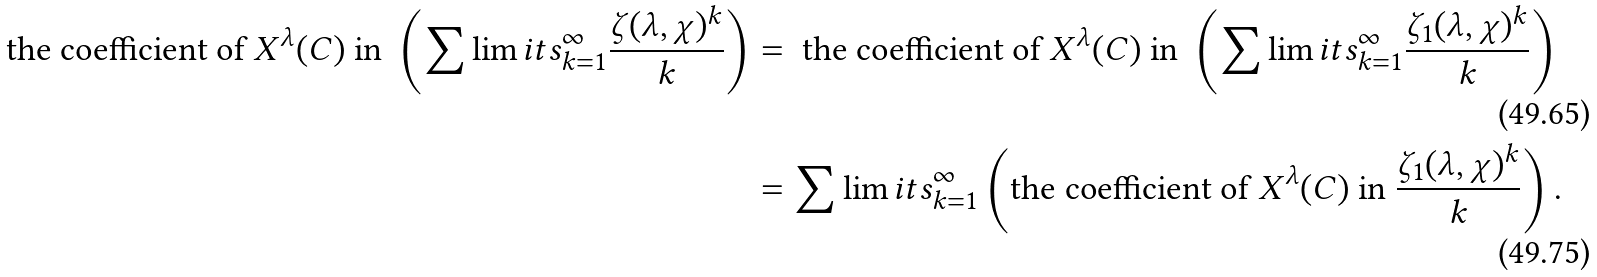Convert formula to latex. <formula><loc_0><loc_0><loc_500><loc_500>\text {the coefficient of} \ X ^ { \lambda } ( C ) \ \text {in} \ \left ( \sum \lim i t s _ { k = 1 } ^ { \infty } \frac { \zeta ( \lambda , \chi ) ^ { k } } { k } \right ) & = \ \text {the coefficient of} \ X ^ { \lambda } ( C ) \ \text {in} \ \left ( \sum \lim i t s _ { k = 1 } ^ { \infty } \frac { \zeta _ { 1 } ( \lambda , \chi ) ^ { k } } { k } \right ) & \\ & = \sum \lim i t s _ { k = 1 } ^ { \infty } \left ( \text {the coefficient of} \ X ^ { \lambda } ( C ) \ \text {in} \ \frac { \zeta _ { 1 } ( \lambda , \chi ) ^ { k } } { k } \right ) .</formula> 